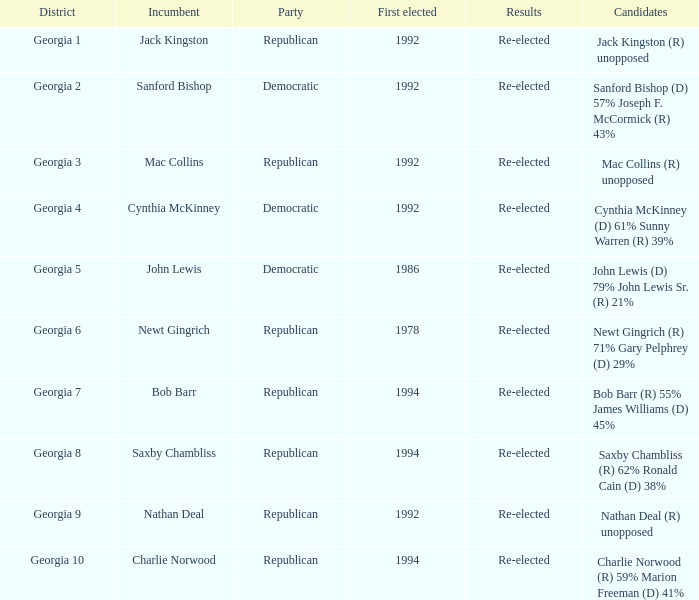Who were the contenders in the election where saxby chambliss was the incumbent? Saxby Chambliss (R) 62% Ronald Cain (D) 38%. 